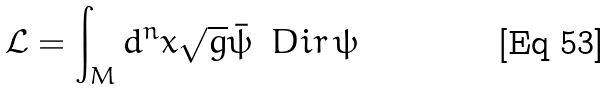Convert formula to latex. <formula><loc_0><loc_0><loc_500><loc_500>\mathcal { L } = \int _ { M } d ^ { n } x \sqrt { g } \bar { \psi } \, \ D i r \, \psi</formula> 